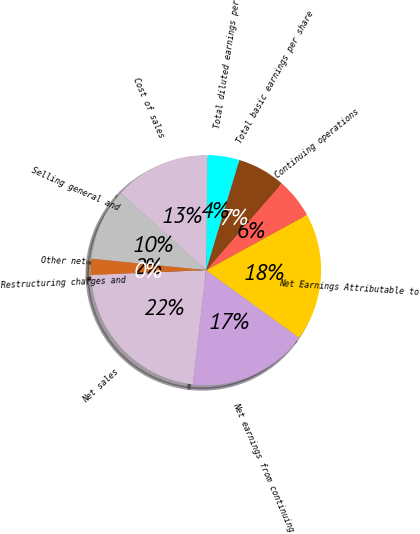<chart> <loc_0><loc_0><loc_500><loc_500><pie_chart><fcel>Net sales<fcel>Net earnings from continuing<fcel>Net Earnings Attributable to<fcel>Continuing operations<fcel>Total basic earnings per share<fcel>Total diluted earnings per<fcel>Cost of sales<fcel>Selling general and<fcel>Other net<fcel>Restructuring charges and<nl><fcel>22.47%<fcel>16.85%<fcel>17.98%<fcel>5.62%<fcel>6.74%<fcel>4.49%<fcel>13.48%<fcel>10.11%<fcel>2.25%<fcel>0.0%<nl></chart> 